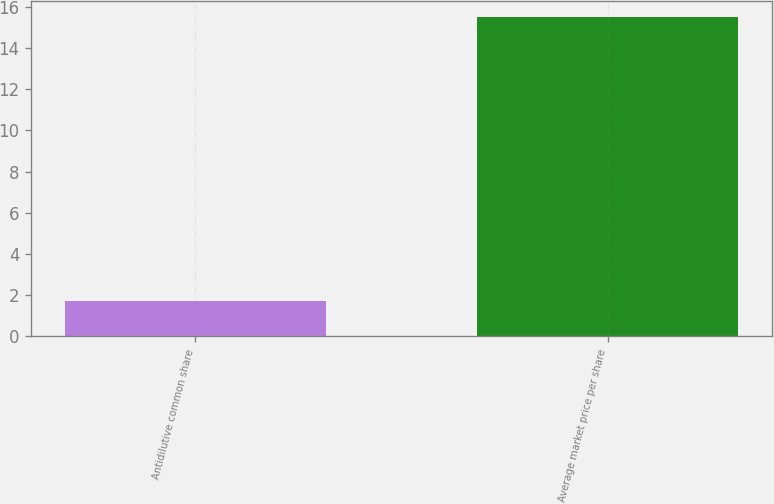Convert chart to OTSL. <chart><loc_0><loc_0><loc_500><loc_500><bar_chart><fcel>Antidilutive common share<fcel>Average market price per share<nl><fcel>1.7<fcel>15.52<nl></chart> 